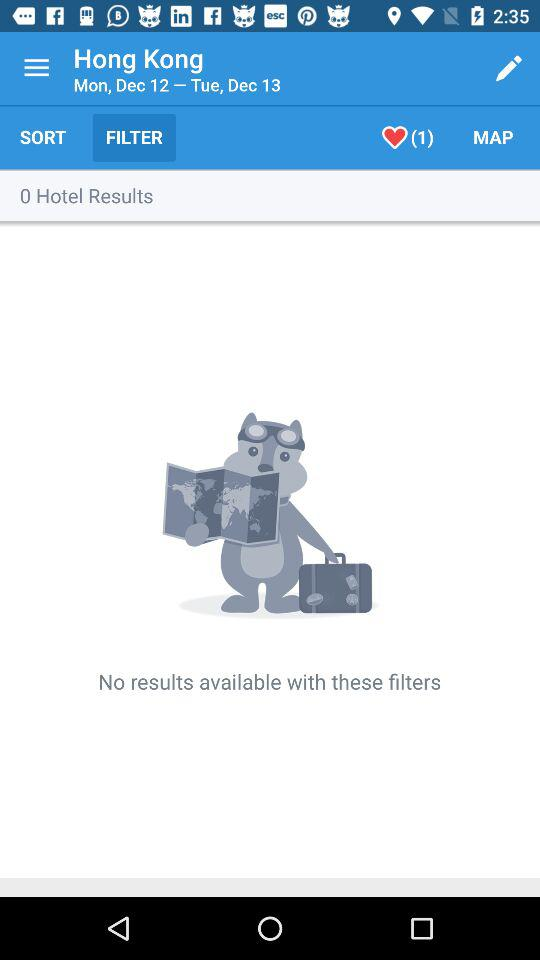What are the mentioned dates? The mentioned dates are Monday, December 12 and Tuesday, December 13. 